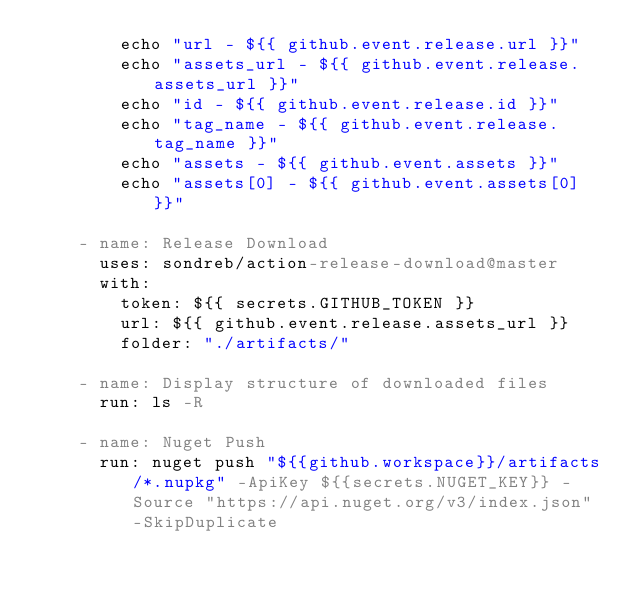Convert code to text. <code><loc_0><loc_0><loc_500><loc_500><_YAML_>        echo "url - ${{ github.event.release.url }}"
        echo "assets_url - ${{ github.event.release.assets_url }}"
        echo "id - ${{ github.event.release.id }}"
        echo "tag_name - ${{ github.event.release.tag_name }}"
        echo "assets - ${{ github.event.assets }}"
        echo "assets[0] - ${{ github.event.assets[0] }}"

    - name: Release Download
      uses: sondreb/action-release-download@master
      with:
        token: ${{ secrets.GITHUB_TOKEN }}
        url: ${{ github.event.release.assets_url }}
        folder: "./artifacts/"

    - name: Display structure of downloaded files
      run: ls -R

    - name: Nuget Push
      run: nuget push "${{github.workspace}}/artifacts/*.nupkg" -ApiKey ${{secrets.NUGET_KEY}} -Source "https://api.nuget.org/v3/index.json" -SkipDuplicate</code> 